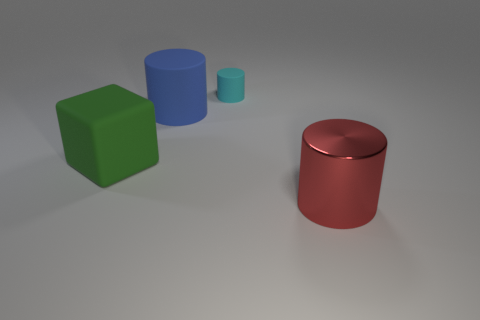There is a red thing that is the same shape as the cyan matte object; what is it made of?
Your answer should be very brief. Metal. How big is the blue cylinder that is on the left side of the small cyan cylinder?
Provide a short and direct response. Large. The big thing behind the matte object to the left of the large blue rubber thing is made of what material?
Offer a very short reply. Rubber. There is a large cylinder on the left side of the metal thing; does it have the same color as the tiny cylinder?
Your answer should be compact. No. Is there any other thing that is made of the same material as the big red cylinder?
Your answer should be compact. No. What number of other shiny things are the same shape as the big metallic thing?
Your answer should be very brief. 0. There is a cyan cylinder that is the same material as the big cube; what is its size?
Ensure brevity in your answer.  Small. Are there any large rubber cylinders that are to the right of the cylinder that is in front of the large object that is on the left side of the blue object?
Offer a terse response. No. Is the size of the cylinder in front of the green cube the same as the tiny cyan cylinder?
Give a very brief answer. No. How many gray shiny spheres have the same size as the blue rubber cylinder?
Keep it short and to the point. 0. 